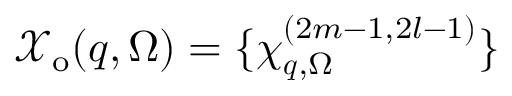Convert formula to latex. <formula><loc_0><loc_0><loc_500><loc_500>\mathcal { X } _ { o } ( q , \Omega ) = \{ \chi _ { q , \Omega } ^ { ( 2 m - 1 , 2 l - 1 ) } \}</formula> 